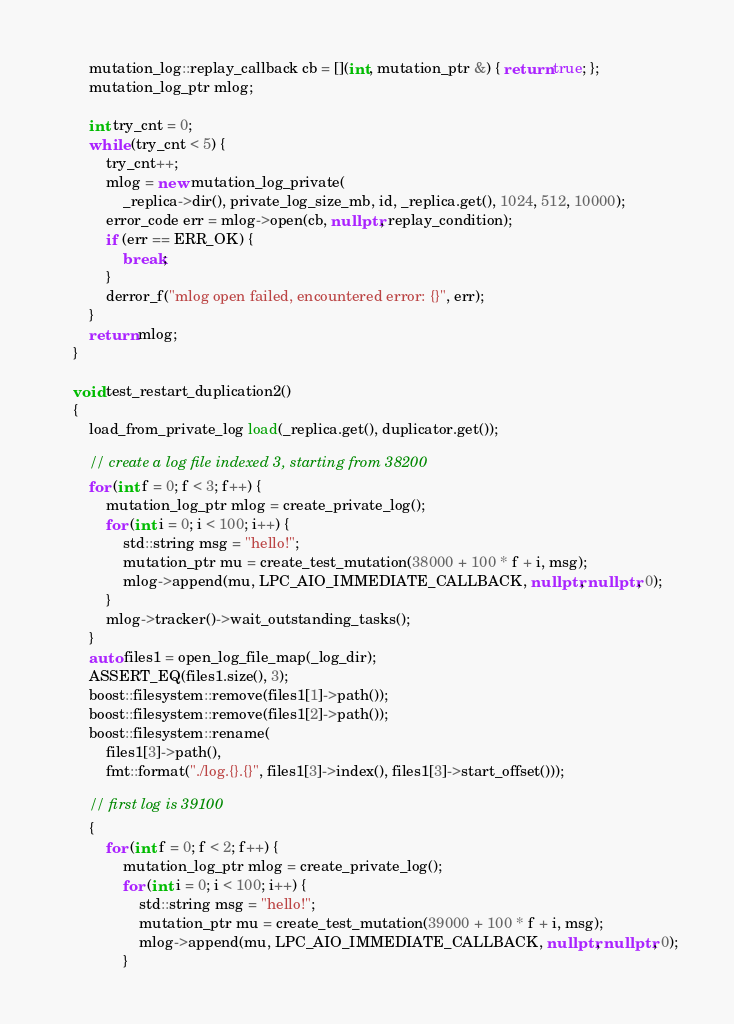Convert code to text. <code><loc_0><loc_0><loc_500><loc_500><_C++_>        mutation_log::replay_callback cb = [](int, mutation_ptr &) { return true; };
        mutation_log_ptr mlog;

        int try_cnt = 0;
        while (try_cnt < 5) {
            try_cnt++;
            mlog = new mutation_log_private(
                _replica->dir(), private_log_size_mb, id, _replica.get(), 1024, 512, 10000);
            error_code err = mlog->open(cb, nullptr, replay_condition);
            if (err == ERR_OK) {
                break;
            }
            derror_f("mlog open failed, encountered error: {}", err);
        }
        return mlog;
    }

    void test_restart_duplication2()
    {
        load_from_private_log load(_replica.get(), duplicator.get());

        // create a log file indexed 3, starting from 38200
        for (int f = 0; f < 3; f++) {
            mutation_log_ptr mlog = create_private_log();
            for (int i = 0; i < 100; i++) {
                std::string msg = "hello!";
                mutation_ptr mu = create_test_mutation(38000 + 100 * f + i, msg);
                mlog->append(mu, LPC_AIO_IMMEDIATE_CALLBACK, nullptr, nullptr, 0);
            }
            mlog->tracker()->wait_outstanding_tasks();
        }
        auto files1 = open_log_file_map(_log_dir);
        ASSERT_EQ(files1.size(), 3);
        boost::filesystem::remove(files1[1]->path());
        boost::filesystem::remove(files1[2]->path());
        boost::filesystem::rename(
            files1[3]->path(),
            fmt::format("./log.{}.{}", files1[3]->index(), files1[3]->start_offset()));

        // first log is 39100
        {
            for (int f = 0; f < 2; f++) {
                mutation_log_ptr mlog = create_private_log();
                for (int i = 0; i < 100; i++) {
                    std::string msg = "hello!";
                    mutation_ptr mu = create_test_mutation(39000 + 100 * f + i, msg);
                    mlog->append(mu, LPC_AIO_IMMEDIATE_CALLBACK, nullptr, nullptr, 0);
                }</code> 